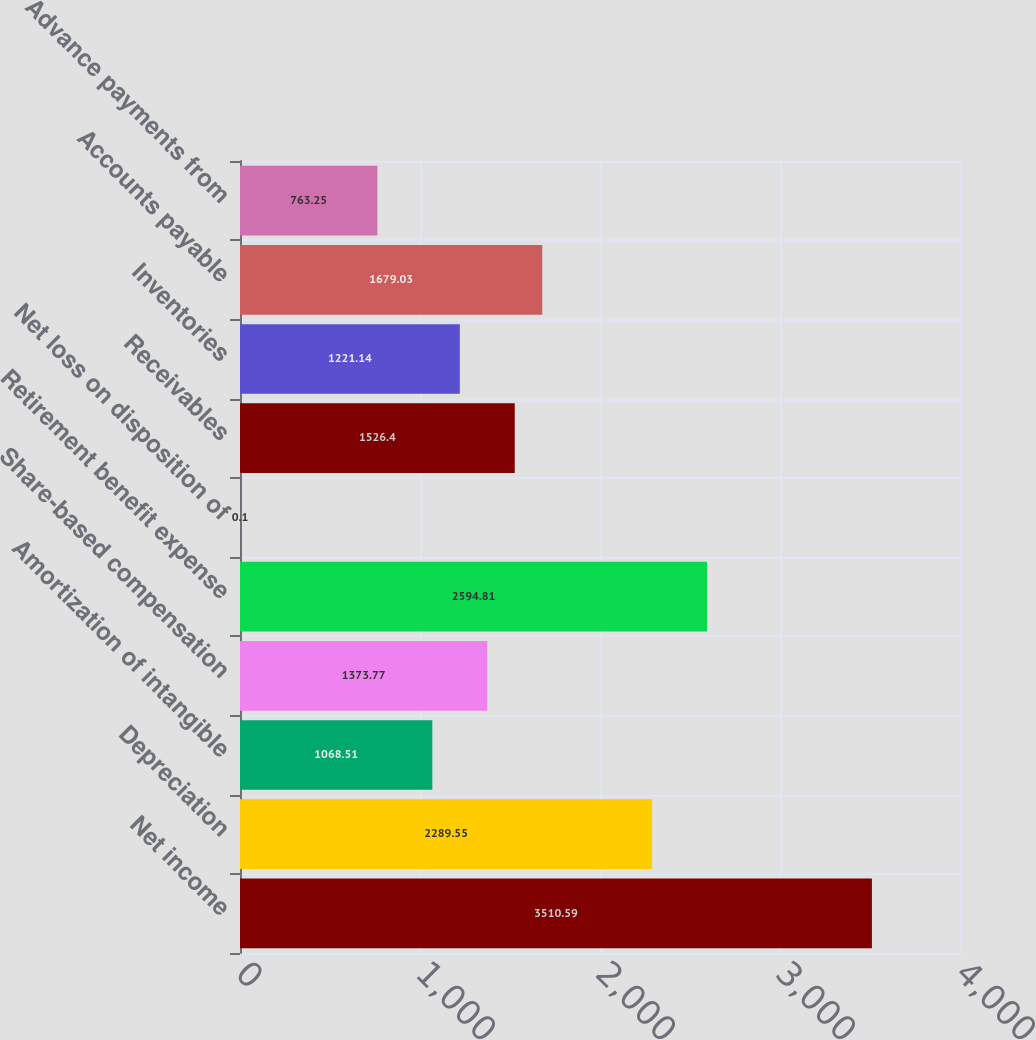Convert chart. <chart><loc_0><loc_0><loc_500><loc_500><bar_chart><fcel>Net income<fcel>Depreciation<fcel>Amortization of intangible<fcel>Share-based compensation<fcel>Retirement benefit expense<fcel>Net loss on disposition of<fcel>Receivables<fcel>Inventories<fcel>Accounts payable<fcel>Advance payments from<nl><fcel>3510.59<fcel>2289.55<fcel>1068.51<fcel>1373.77<fcel>2594.81<fcel>0.1<fcel>1526.4<fcel>1221.14<fcel>1679.03<fcel>763.25<nl></chart> 